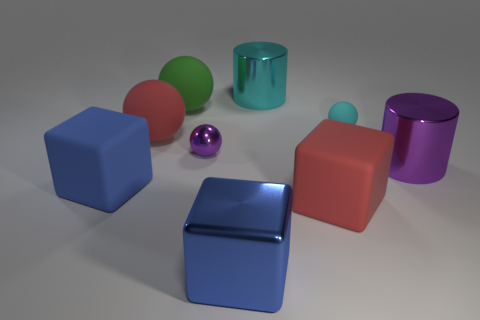There is a purple object that is the same shape as the green thing; what is its material?
Offer a terse response. Metal. There is a large rubber thing that is on the right side of the large matte thing that is behind the big red thing behind the big purple shiny cylinder; what color is it?
Provide a succinct answer. Red. How many objects are either red rubber spheres or rubber objects?
Provide a succinct answer. 5. How many large purple objects are the same shape as the small cyan matte object?
Provide a succinct answer. 0. Are the small cyan object and the cyan thing behind the small cyan rubber sphere made of the same material?
Your answer should be compact. No. There is a blue cube that is the same material as the big green sphere; what is its size?
Give a very brief answer. Large. How big is the purple metal thing in front of the purple metal ball?
Your response must be concise. Large. What number of blocks have the same size as the blue metallic thing?
Offer a very short reply. 2. What is the size of the matte object that is the same color as the large metallic cube?
Keep it short and to the point. Large. Is there a cylinder of the same color as the large metal block?
Provide a short and direct response. No. 